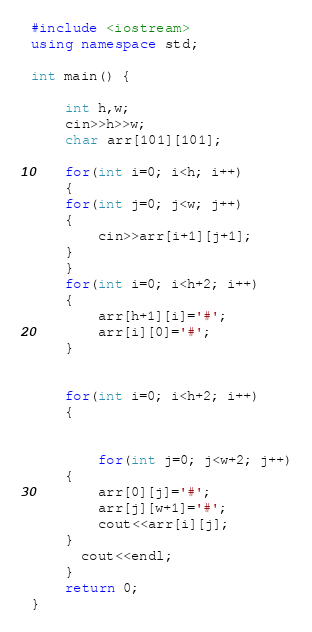Convert code to text. <code><loc_0><loc_0><loc_500><loc_500><_C++_>#include <iostream>
using namespace std;

int main() {
	
	int h,w;
	cin>>h>>w;
	char arr[101][101];
	
	for(int i=0; i<h; i++)
	{
	for(int j=0; j<w; j++)
	{
		cin>>arr[i+1][j+1];
	}
	}
	for(int i=0; i<h+2; i++)
	{
		arr[h+1][i]='#';
		arr[i][0]='#';
	}
	
	
	for(int i=0; i<h+2; i++)
	{
                       
		
		for(int j=0; j<w+2; j++)
	{
		arr[0][j]='#';
		arr[j][w+1]='#';
		cout<<arr[i][j];
	}
	  cout<<endl;
	}
	return 0;
}</code> 